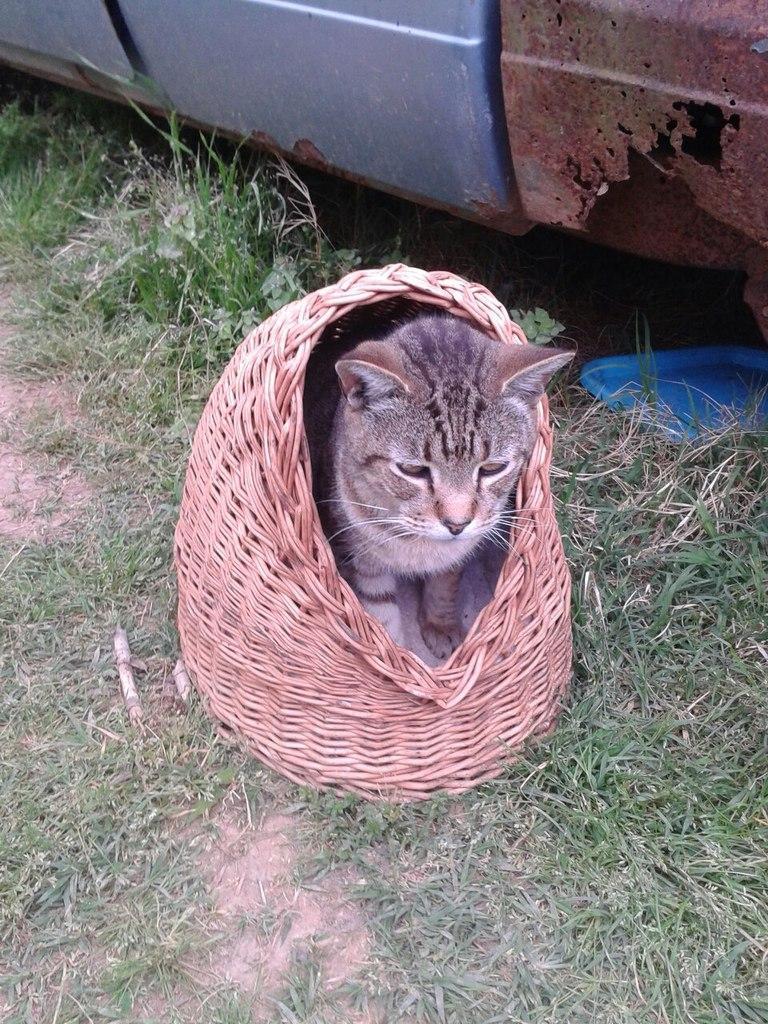Can you describe this image briefly? In the middle of the image, there is a cat standing in the wooden basket. Which is placed on the ground, on which there is grass. Beside this basket, there is a vehicle. 